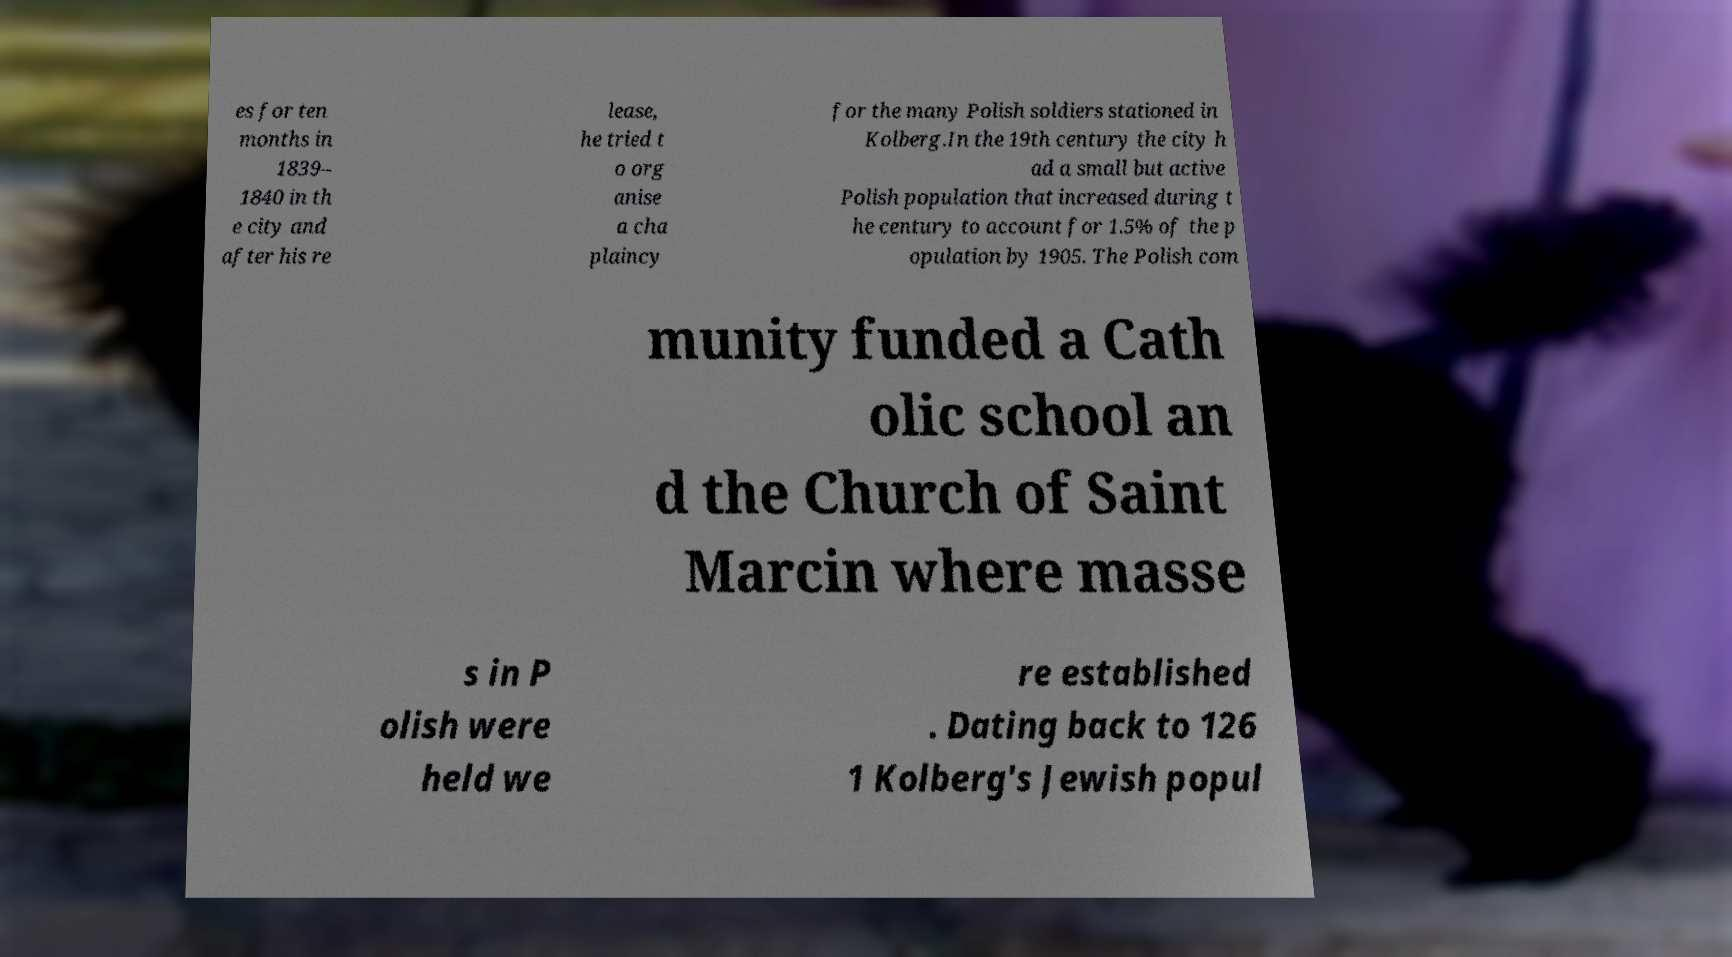I need the written content from this picture converted into text. Can you do that? es for ten months in 1839– 1840 in th e city and after his re lease, he tried t o org anise a cha plaincy for the many Polish soldiers stationed in Kolberg.In the 19th century the city h ad a small but active Polish population that increased during t he century to account for 1.5% of the p opulation by 1905. The Polish com munity funded a Cath olic school an d the Church of Saint Marcin where masse s in P olish were held we re established . Dating back to 126 1 Kolberg's Jewish popul 